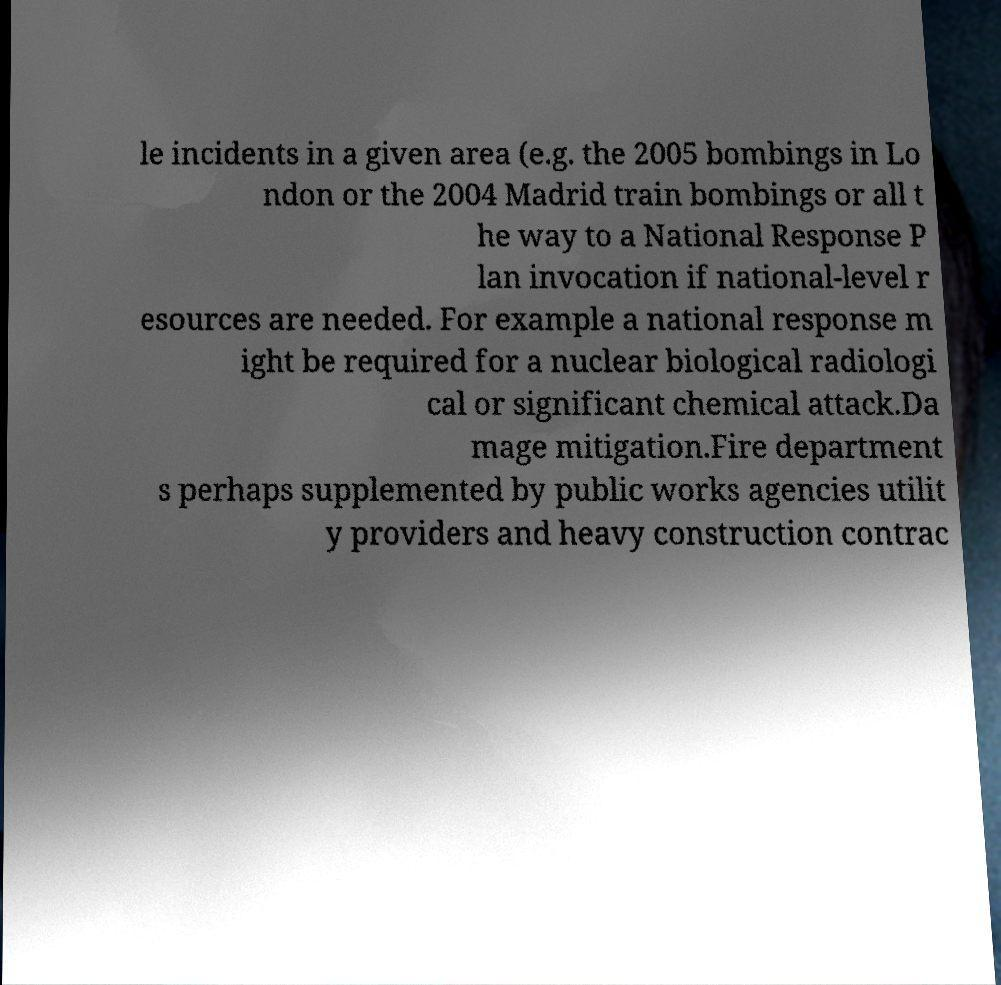I need the written content from this picture converted into text. Can you do that? le incidents in a given area (e.g. the 2005 bombings in Lo ndon or the 2004 Madrid train bombings or all t he way to a National Response P lan invocation if national-level r esources are needed. For example a national response m ight be required for a nuclear biological radiologi cal or significant chemical attack.Da mage mitigation.Fire department s perhaps supplemented by public works agencies utilit y providers and heavy construction contrac 